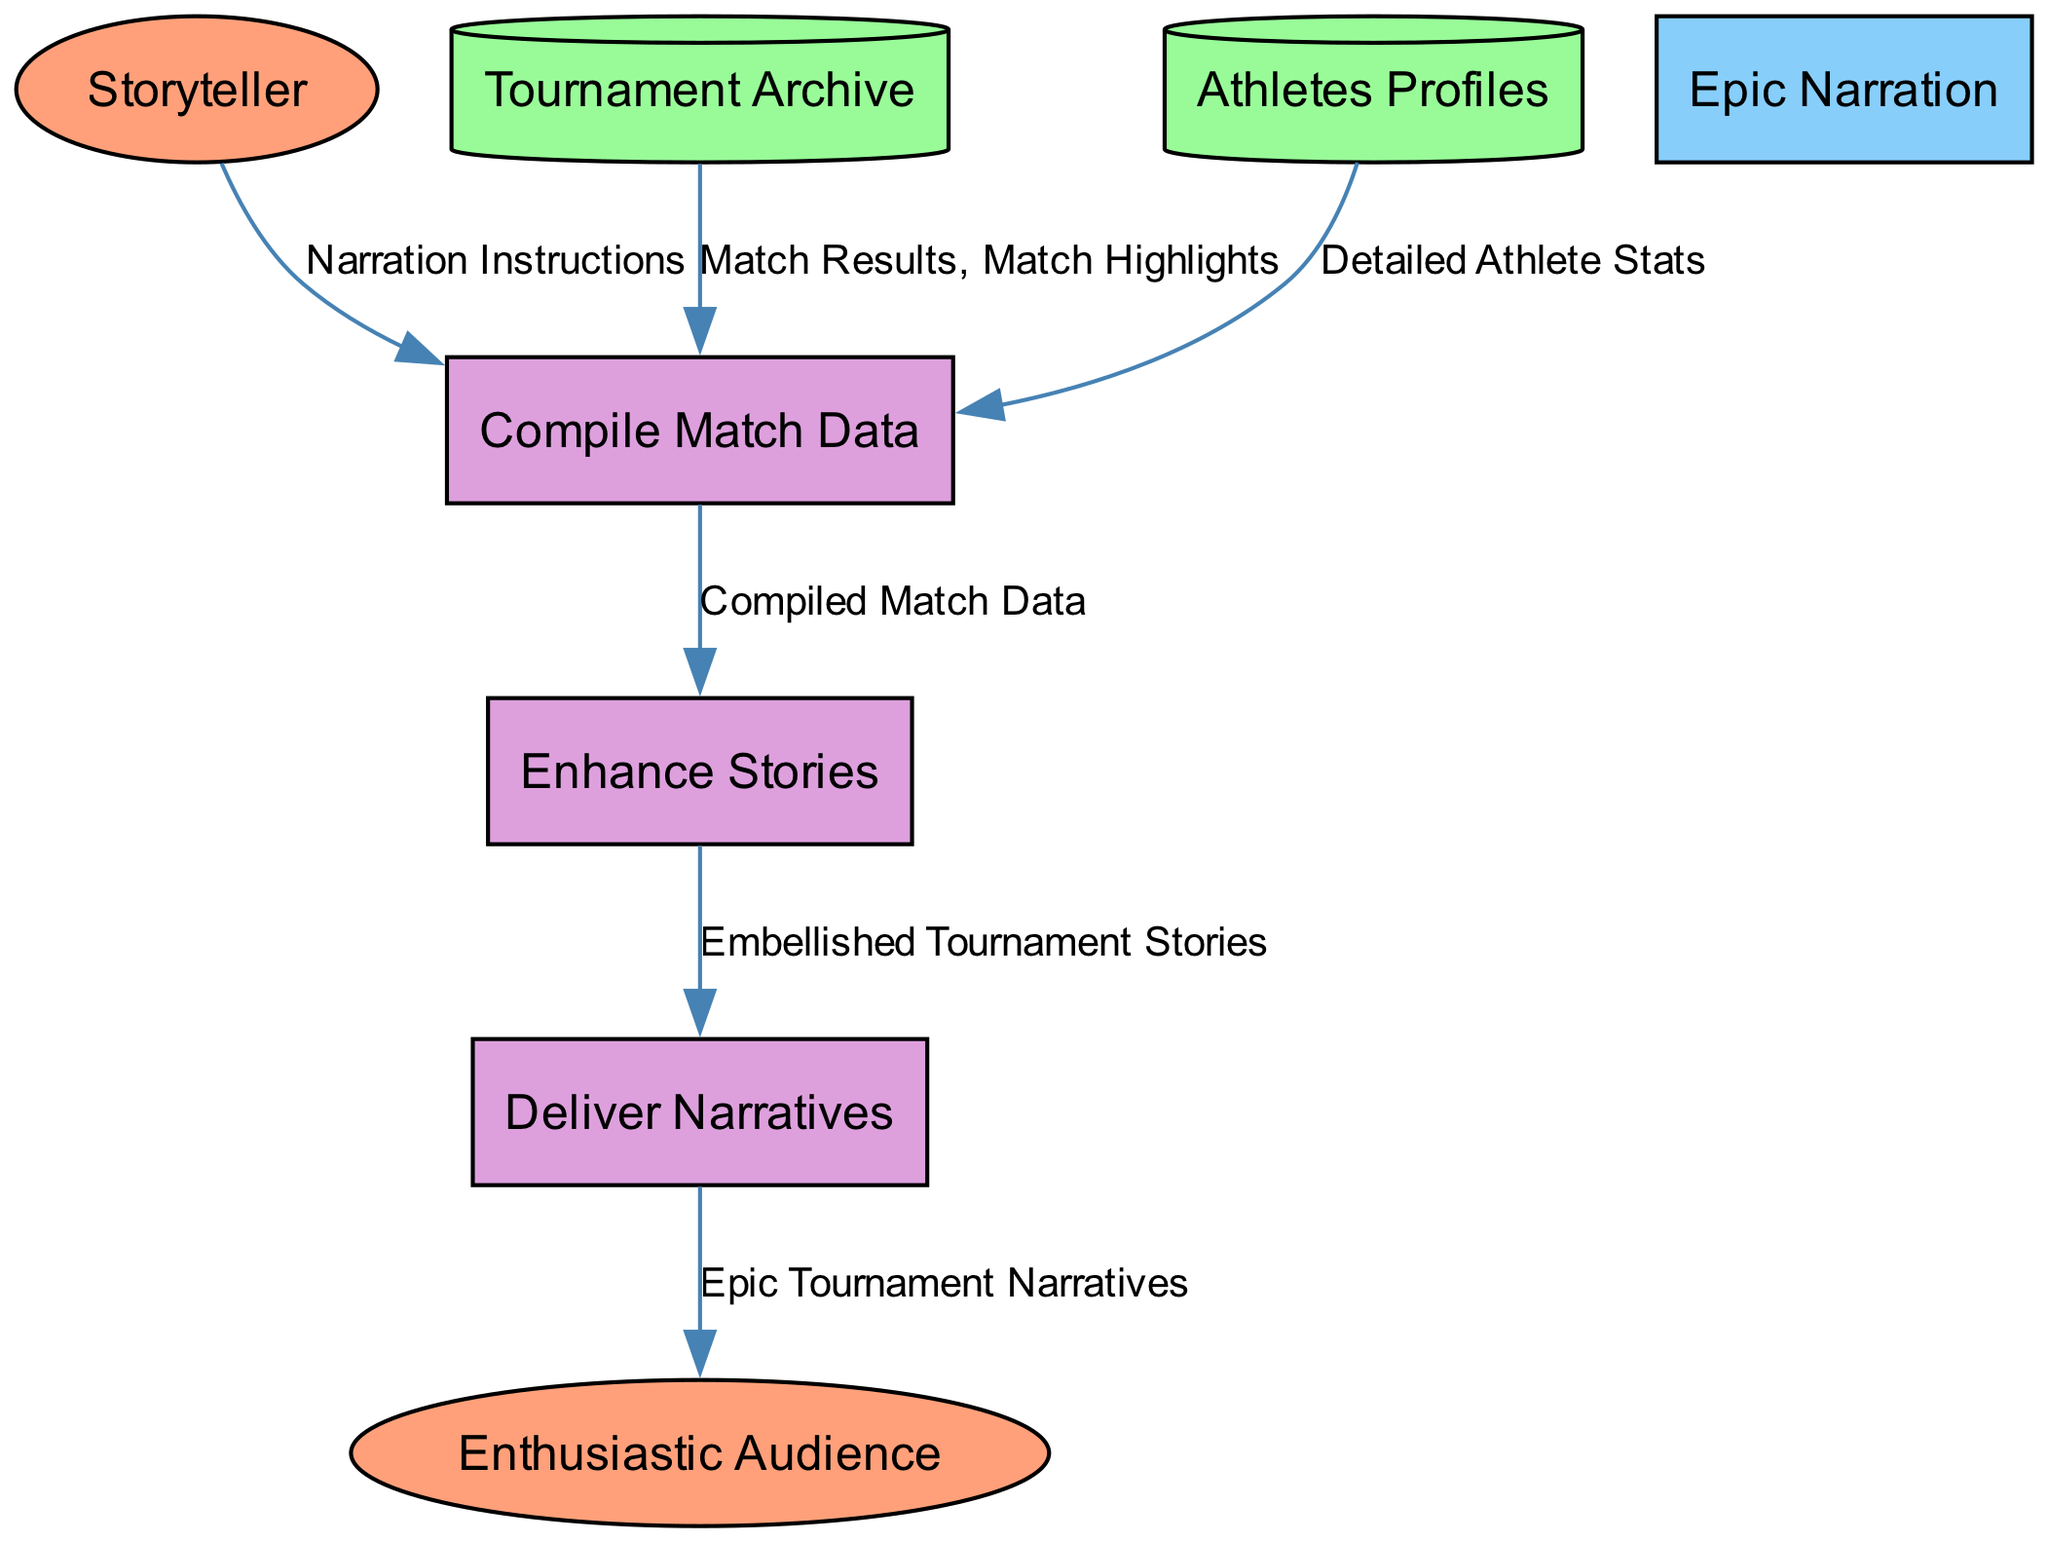What is the first process in the diagram? The first process in the diagram is listed as "Compile Match Data". It is the initial step that collects data from various sources before moving to enhance the stories.
Answer: Compile Match Data How many external entities are present in the diagram? There are two external entities in the diagram: "Storyteller" and "Enthusiastic Audience". These entities represent the key participants outside the data processes.
Answer: 2 What type of data store is "Tournament Archive"? "Tournament Archive" is classified as a Data Store. This is indicated by its description and representation within the diagram matrix.
Answer: Data Store Which process flows data to "Deliver Narratives"? The process that flows data to "Deliver Narratives" is "Enhance Stories". It takes the embellished stories and delivers them to the audience.
Answer: Enhance Stories What flows from "Compile Match Data" to "Enhance Stories"? "Compiled Match Data" flows from "Compile Match Data" to "Enhance Stories". This indicates that the output of the compiling process is being enhanced for storytelling.
Answer: Compiled Match Data Which entity provides "Narration Instructions"? The entity that provides "Narration Instructions" is the "Storyteller". This shows the storyteller's role in guiding how the data should be compiled.
Answer: Storyteller What type of data flows from "Tournament Archive" to "Compile Match Data"? The data flowing from "Tournament Archive" to "Compile Match Data" includes "Match Results" and "Match Highlights". These are critical for input into the compilation process.
Answer: Match Results, Match Highlights How many processes are illustrated in the diagram? There are three processes illustrated in the diagram: "Compile Match Data", "Enhance Stories", and "Deliver Narratives". This shows the stepwise progression of storytelling.
Answer: 3 Which external entity is the final recipient of the narratives? The final recipient of the narratives is the "Enthusiastic Audience". This indicates who the embellished stories are conveyed to after enhancement.
Answer: Enthusiastic Audience 